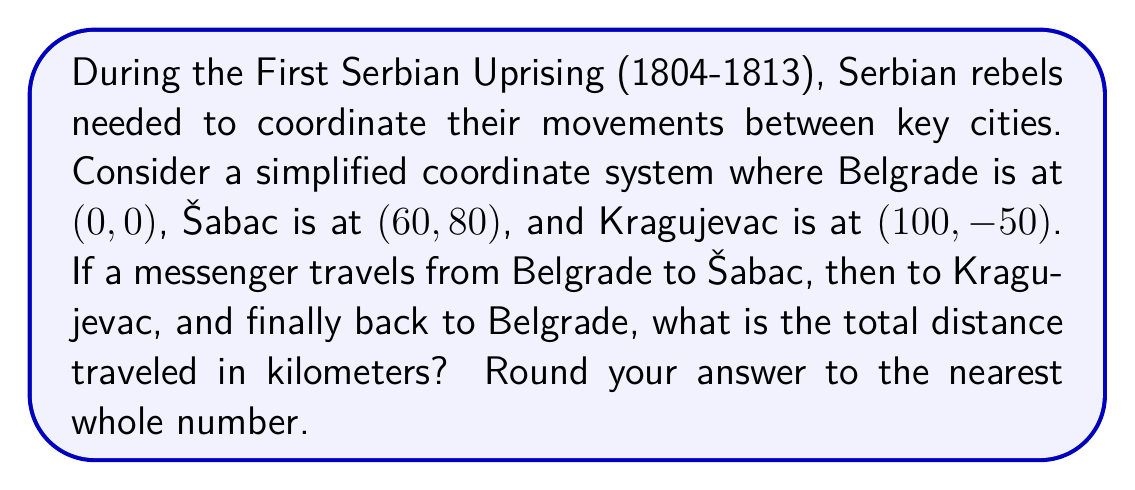Can you answer this question? To solve this problem, we need to calculate the distances between each pair of cities and then sum them up. We can use the distance formula between two points on a coordinate plane:

$$d = \sqrt{(x_2 - x_1)^2 + (y_2 - y_1)^2}$$

1. Distance from Belgrade (0, 0) to Šabac (60, 80):
   $$d_{1} = \sqrt{(60 - 0)^2 + (80 - 0)^2} = \sqrt{3600 + 6400} = \sqrt{10000} = 100\text{ km}$$

2. Distance from Šabac (60, 80) to Kragujevac (100, -50):
   $$d_{2} = \sqrt{(100 - 60)^2 + (-50 - 80)^2} = \sqrt{1600 + 16900} = \sqrt{18500} \approx 136.01\text{ km}$$

3. Distance from Kragujevac (100, -50) back to Belgrade (0, 0):
   $$d_{3} = \sqrt{(0 - 100)^2 + (0 - (-50))^2} = \sqrt{10000 + 2500} = \sqrt{12500} \approx 111.80\text{ km}$$

Total distance:
$$d_{\text{total}} = d_{1} + d_{2} + d_{3} = 100 + 136.01 + 111.80 = 347.81\text{ km}$$

Rounding to the nearest whole number: 348 km
Answer: 348 km 